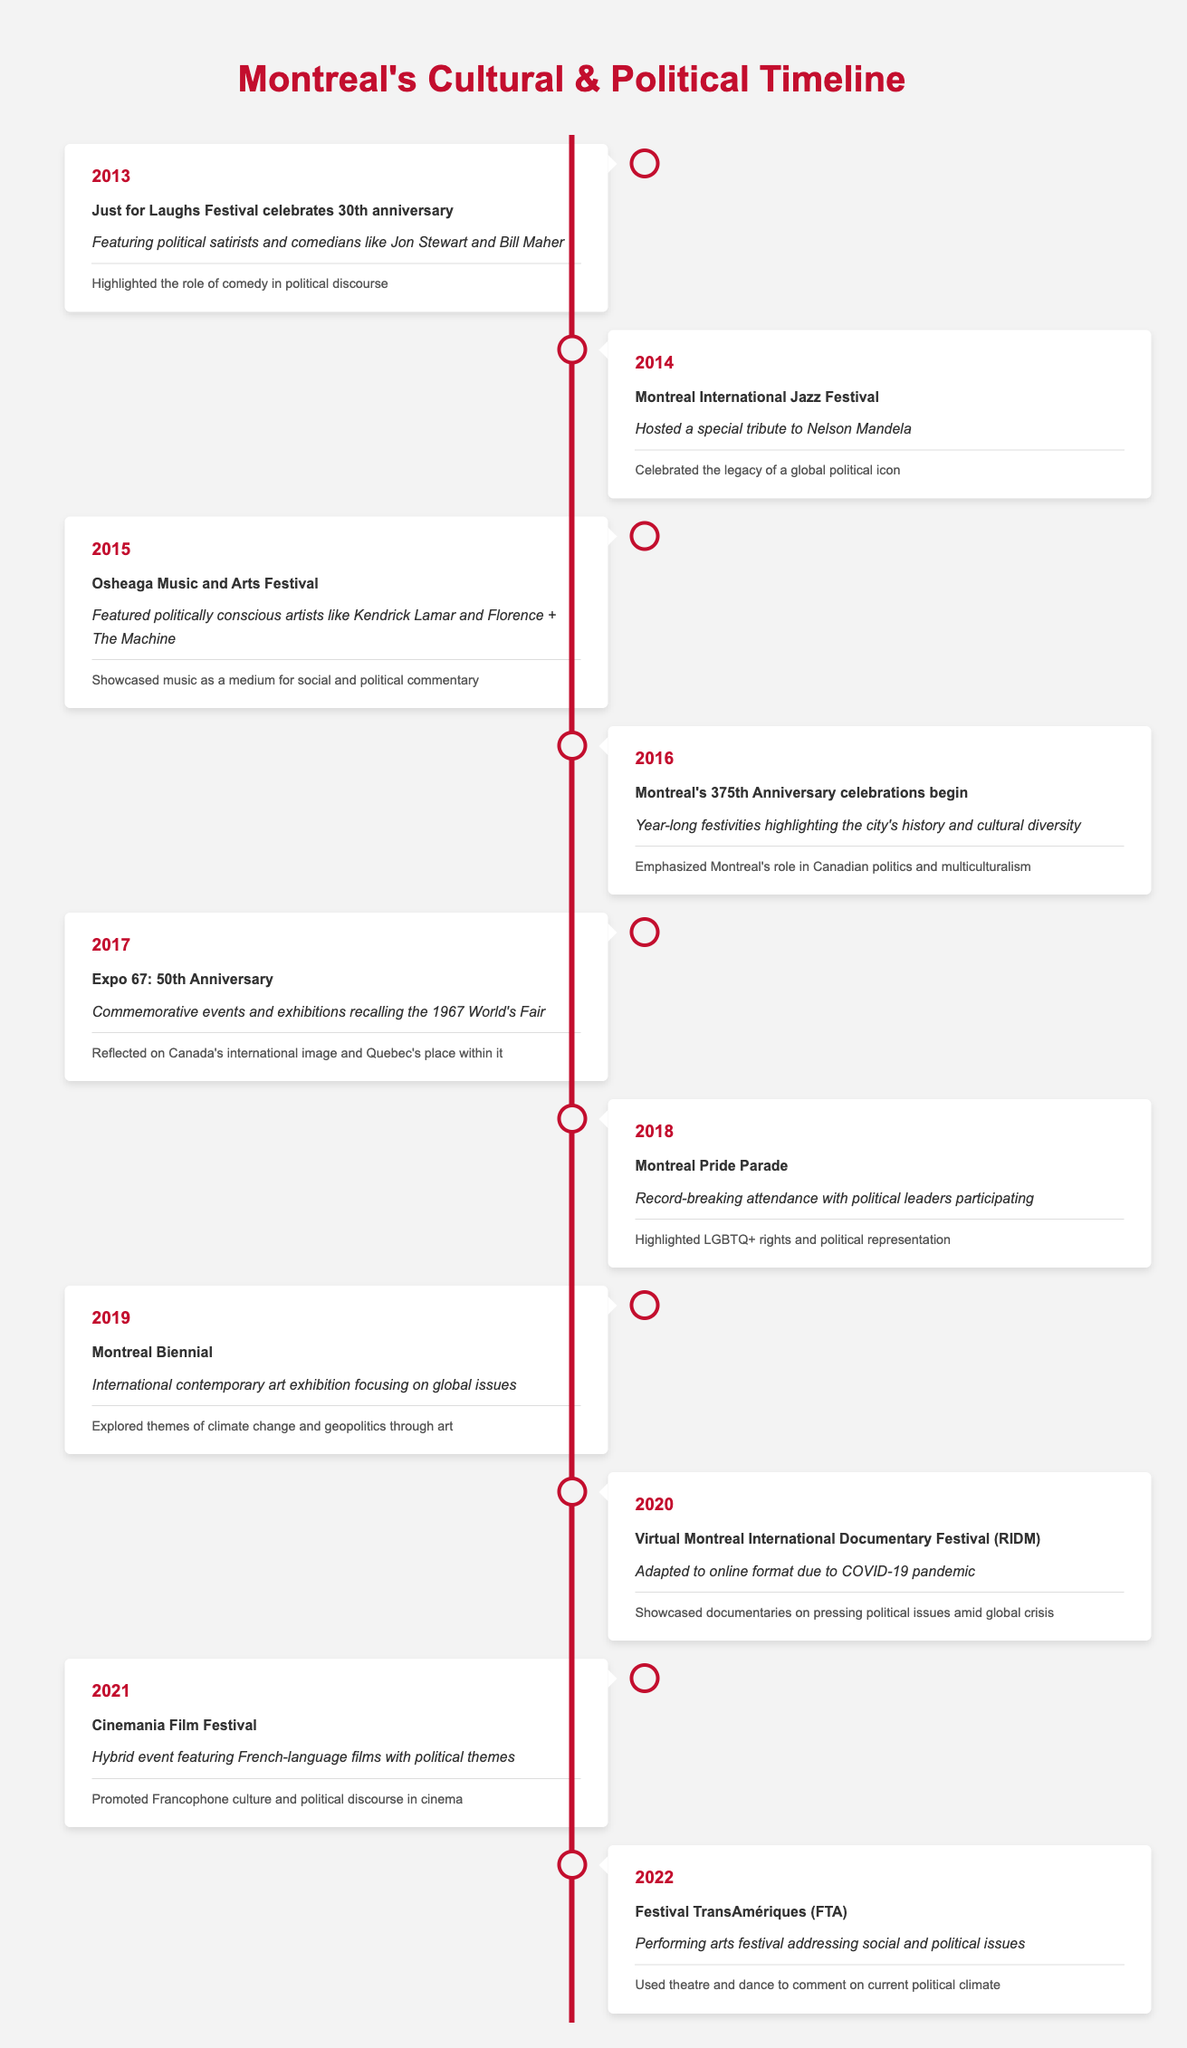What event celebrated its 30th anniversary in 2013? In the 2013 row, the event listed is the "Just for Laughs Festival," which celebrated its 30th anniversary.
Answer: Just for Laughs Festival Which festival in 2014 hosted a tribute to a global political icon? The event in 2014 is the "Montreal International Jazz Festival," which hosted a special tribute to Nelson Mandela.
Answer: Montreal International Jazz Festival How many events highlighted LGBTQ+ rights between 2013 and 2022? The event highlighting LGBTQ+ rights is the "Montreal Pride Parade" in 2018, making it a total of one event during this period.
Answer: 1 What year did Montreal begin celebrating its 375th Anniversary? The timeline indicates that Montreal's 375th Anniversary celebrations began in 2016, as stated in that year's entry.
Answer: 2016 Which two events focused on global issues in 2019? The two events in 2019 focusing on global issues are the "Montreal Biennial," which addressed climate change and geopolitics through art.
Answer: Montreal Biennial Did the 2020 event adapt due to the COVID-19 pandemic? Yes, the "Virtual Montreal International Documentary Festival (RIDM)" adapted to an online format due to the COVID-19 pandemic.
Answer: Yes How many years were there between Montreal's 375th Anniversary celebrations and the Montreal Pride Parade? The 375th Anniversary celebrations began in 2016, and Montreal Pride Parade occurred in 2018. The difference is 2018 - 2016 = 2 years.
Answer: 2 What was the political significance of the Osheaga Music and Arts Festival held in 2015? The political significance stated for the Osheaga Music and Arts Festival is that it showcased music as a medium for social and political commentary.
Answer: Showcased music as a medium for social and political commentary What is the overarching theme of the Festival TransAmériques in 2022? The festival addressed social and political issues, using theatre and dance to comment on the current political climate.
Answer: Addressed social and political issues 